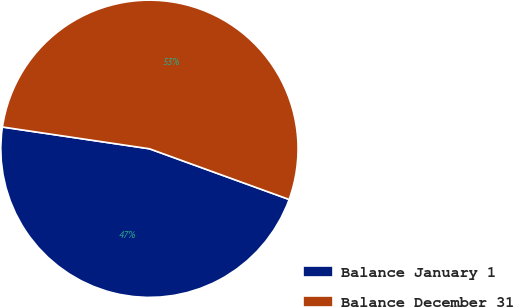Convert chart. <chart><loc_0><loc_0><loc_500><loc_500><pie_chart><fcel>Balance January 1<fcel>Balance December 31<nl><fcel>46.8%<fcel>53.2%<nl></chart> 